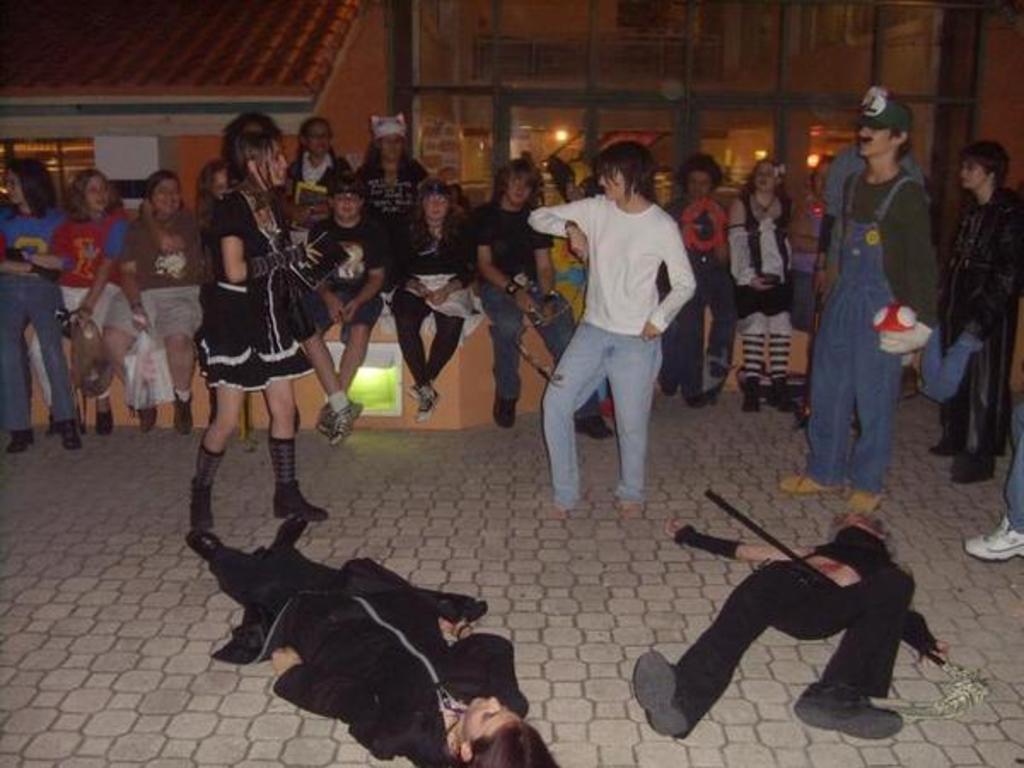How would you summarize this image in a sentence or two? In the foreground of this image, on the ground, there are two persons lying down. In the background, there is the crowd few are standing and few are sitting and there is a glass wall and a house in the background. 